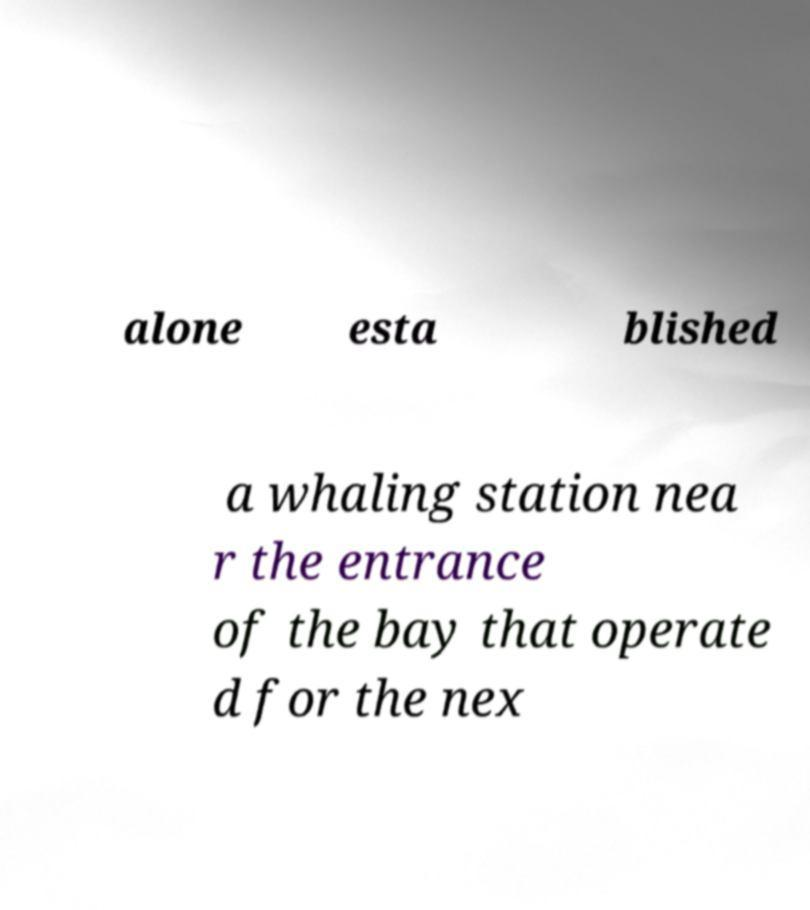I need the written content from this picture converted into text. Can you do that? alone esta blished a whaling station nea r the entrance of the bay that operate d for the nex 